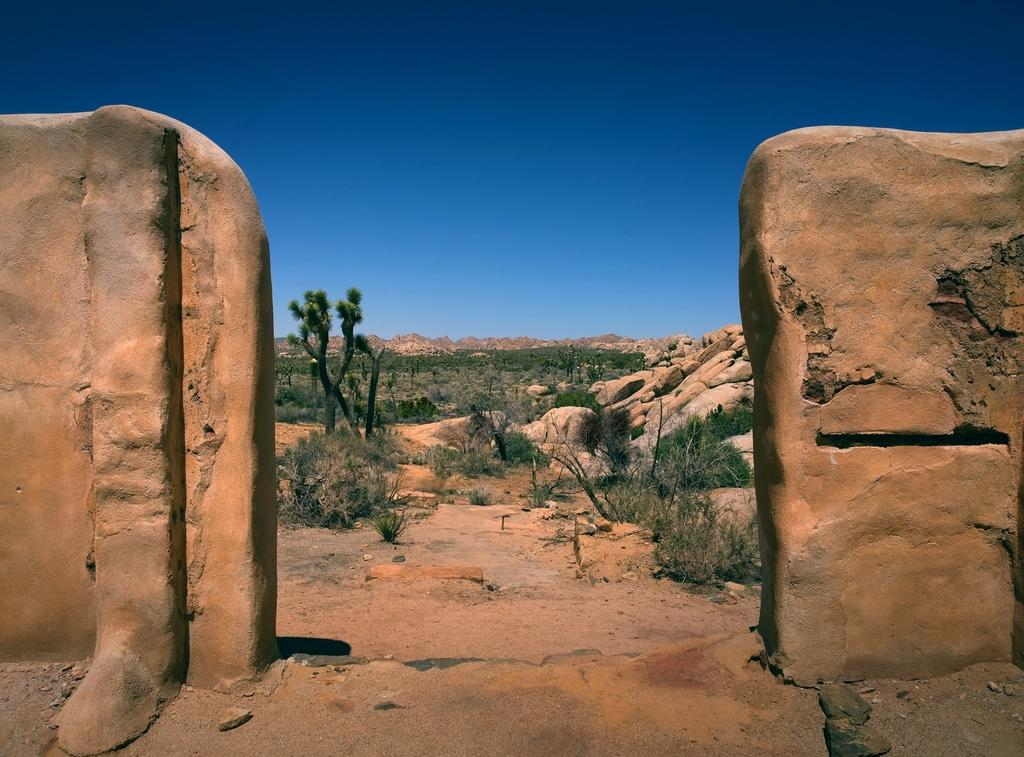What type of natural elements can be seen in the image? There are rocks, trees, plants, grass, and stones visible in the image. What type of terrain is depicted in the image? The image shows hills, which suggests a hilly or mountainous landscape. What is visible in the background of the image? The sky is visible in the image. What type of station can be seen in the image? There is no station present in the image; it features natural elements such as rocks, trees, plants, grass, stones, and hills. Can you see a rat in the image? There is no rat present in the image. 